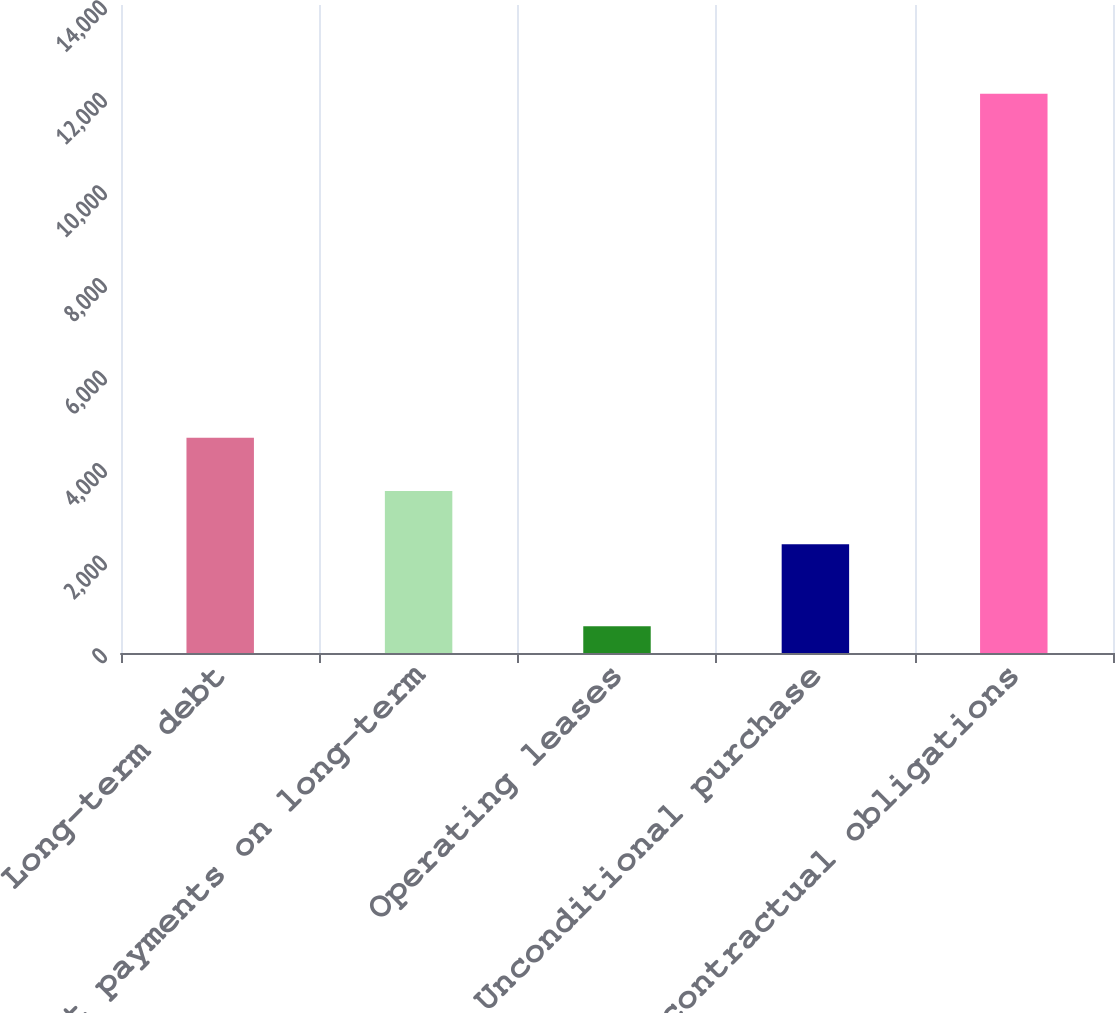Convert chart to OTSL. <chart><loc_0><loc_0><loc_500><loc_500><bar_chart><fcel>Long-term debt<fcel>Interest payments on long-term<fcel>Operating leases<fcel>Unconditional purchase<fcel>Total contractual obligations<nl><fcel>4652<fcel>3501.5<fcel>577<fcel>2351<fcel>12082<nl></chart> 